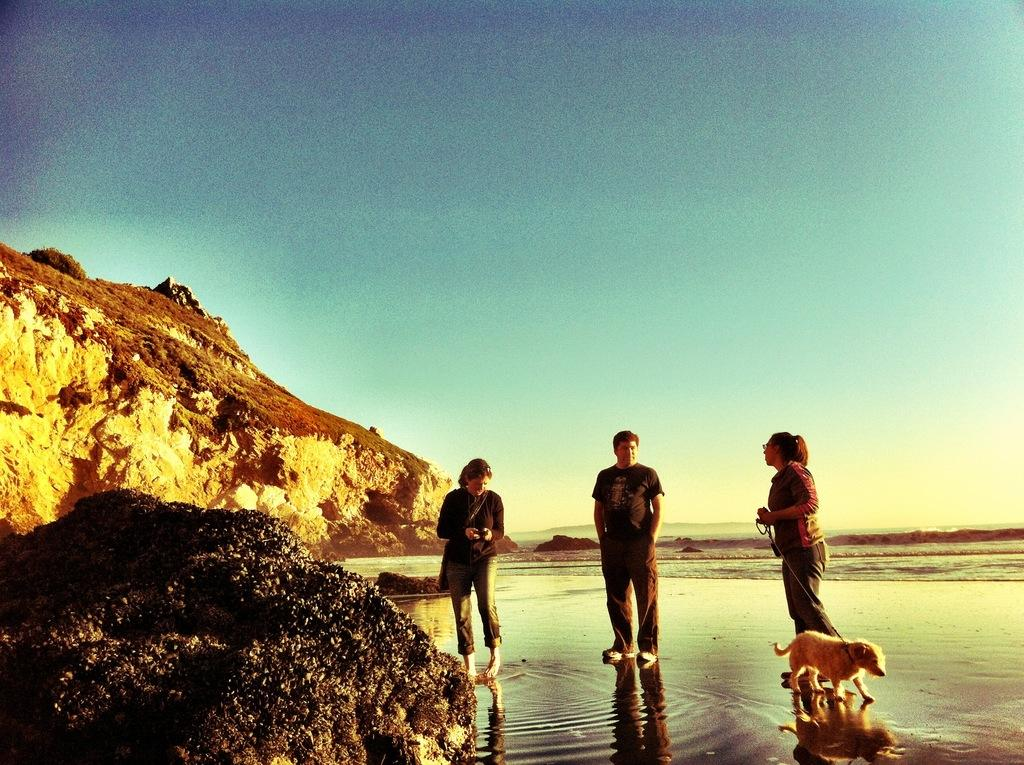What is located at the front of the image? There is a stone in the front of the image. What can be seen in the center of the image? There are persons standing in the center of the image. What type of animal is present in the image? There is a dog in the image. What is visible in the background of the image? There is water and a mountain visible in the background of the image. What shape is the cow in the image? There is no cow present in the image. What is the texture of the chin of the person in the image? There is no chin visible in the image, as the persons are standing and not shown in a close-up view. 